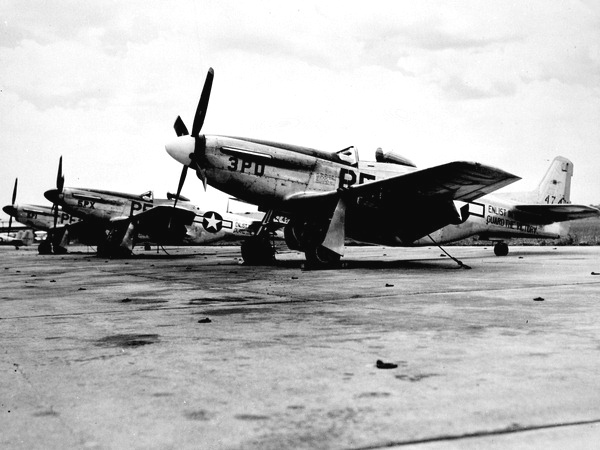Can you tell me what era these aircraft are from? Based on the design and markings, these aircraft appear to be P-51 Mustangs, which were predominantly used by the United States during World War II. This suggests that the image dates back to somewhere between 1942 and 1945, the period during which these aircraft were most active in the war effort. 